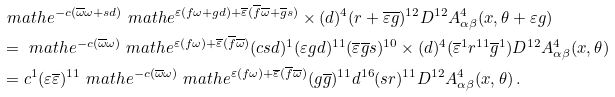Convert formula to latex. <formula><loc_0><loc_0><loc_500><loc_500>& \ m a t h e ^ { - c ( \overline { \omega } \omega + s d ) } \ m a t h e ^ { \varepsilon ( f \omega + g d ) + \overline { \varepsilon } ( \overline { f } \overline { \omega } + \overline { g } s ) } \times ( d ) ^ { 4 } ( r + \overline { \varepsilon } \overline { g } ) ^ { 1 2 } D ^ { 1 2 } A ^ { 4 } _ { \alpha \beta } ( x , \theta + \varepsilon g ) \\ & = \ m a t h e ^ { - c ( \overline { \omega } \omega ) } \ m a t h e ^ { \varepsilon ( f \omega ) + \overline { \varepsilon } ( \overline { f } \overline { \omega } ) } ( c s d ) ^ { 1 } ( \varepsilon g d ) ^ { 1 1 } ( \overline { \varepsilon } \overline { g } s ) ^ { 1 0 } \times ( d ) ^ { 4 } ( \overline { \varepsilon } ^ { 1 } r ^ { 1 1 } \overline { g } ^ { 1 } ) D ^ { 1 2 } A ^ { 4 } _ { \alpha \beta } ( x , \theta ) \\ & = c ^ { 1 } ( \varepsilon \overline { \varepsilon } ) ^ { 1 1 } \ m a t h e ^ { - c ( \overline { \omega } \omega ) } \ m a t h e ^ { \varepsilon ( f \omega ) + \overline { \varepsilon } ( \overline { f } \overline { \omega } ) } ( g \overline { g } ) ^ { 1 1 } d ^ { 1 6 } ( s r ) ^ { 1 1 } D ^ { 1 2 } A ^ { 4 } _ { \alpha \beta } ( x , \theta ) \, .</formula> 